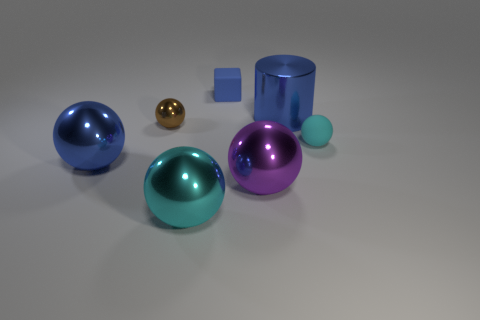Does the tiny cyan object have the same shape as the small blue object?
Provide a succinct answer. No. How many metallic balls are both in front of the cyan matte thing and on the left side of the big cyan object?
Offer a terse response. 1. What number of objects are blue matte blocks or tiny blue rubber cubes on the right side of the tiny brown metallic thing?
Give a very brief answer. 1. Is the number of big metal cylinders greater than the number of big blue metal objects?
Keep it short and to the point. No. There is a shiny object that is in front of the purple object; what shape is it?
Your response must be concise. Sphere. What number of purple metallic things have the same shape as the cyan matte thing?
Ensure brevity in your answer.  1. There is a cyan thing left of the blue shiny object behind the small cyan thing; what size is it?
Your response must be concise. Large. How many yellow things are either tiny shiny balls or big shiny cylinders?
Offer a very short reply. 0. Is the number of blue metallic cylinders on the right side of the big blue cylinder less than the number of big blue metal cylinders left of the tiny metallic ball?
Your answer should be compact. No. There is a purple metallic ball; is it the same size as the cyan sphere that is behind the large cyan metallic sphere?
Your answer should be very brief. No. 